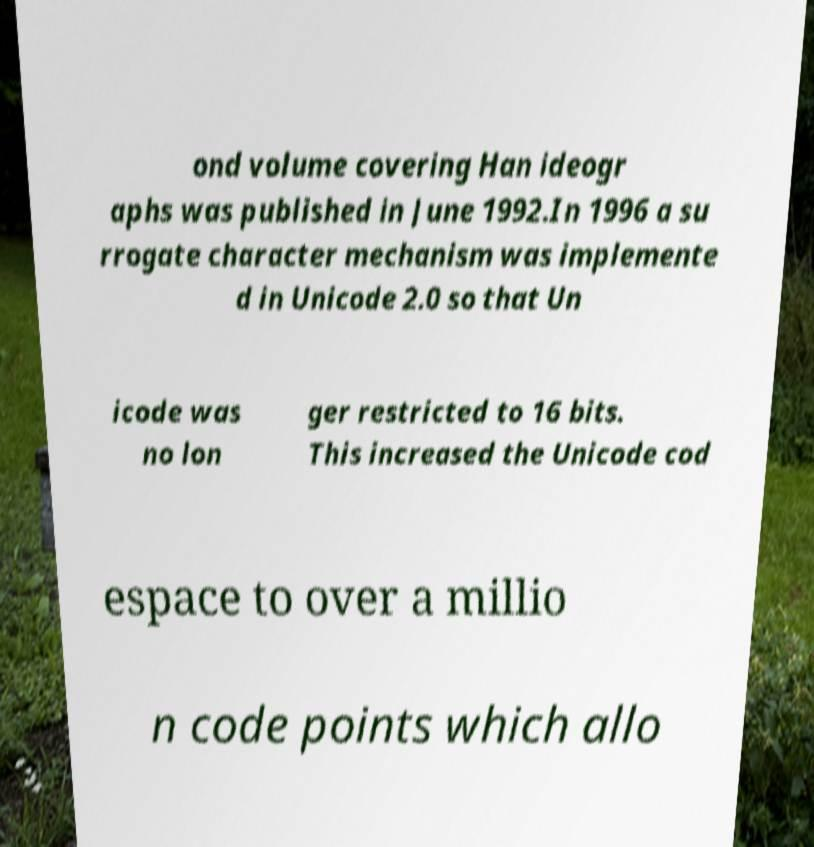Can you accurately transcribe the text from the provided image for me? ond volume covering Han ideogr aphs was published in June 1992.In 1996 a su rrogate character mechanism was implemente d in Unicode 2.0 so that Un icode was no lon ger restricted to 16 bits. This increased the Unicode cod espace to over a millio n code points which allo 